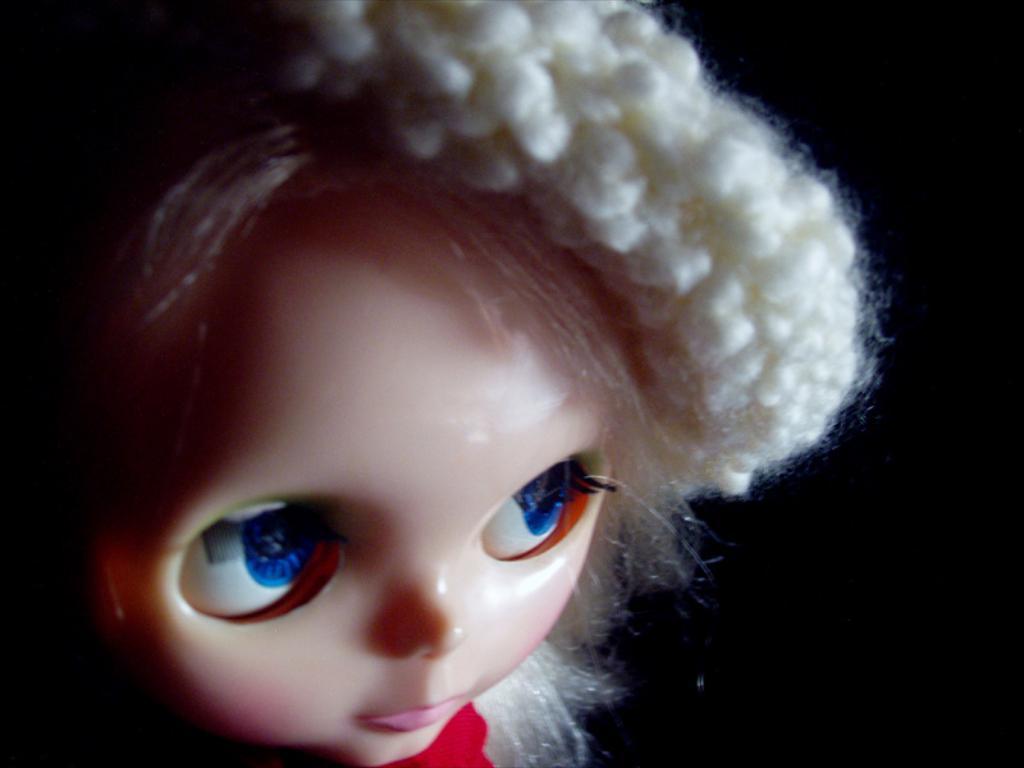Describe this image in one or two sentences. This image consists of a doll. The background is too dark. 